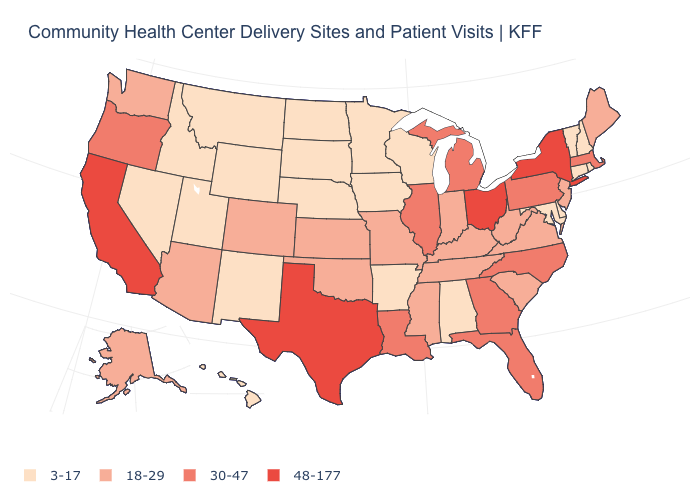Among the states that border New Jersey , does New York have the highest value?
Answer briefly. Yes. How many symbols are there in the legend?
Quick response, please. 4. Name the states that have a value in the range 3-17?
Write a very short answer. Alabama, Arkansas, Connecticut, Delaware, Hawaii, Idaho, Iowa, Maryland, Minnesota, Montana, Nebraska, Nevada, New Hampshire, New Mexico, North Dakota, Rhode Island, South Dakota, Utah, Vermont, Wisconsin, Wyoming. Name the states that have a value in the range 3-17?
Keep it brief. Alabama, Arkansas, Connecticut, Delaware, Hawaii, Idaho, Iowa, Maryland, Minnesota, Montana, Nebraska, Nevada, New Hampshire, New Mexico, North Dakota, Rhode Island, South Dakota, Utah, Vermont, Wisconsin, Wyoming. Name the states that have a value in the range 18-29?
Write a very short answer. Alaska, Arizona, Colorado, Indiana, Kansas, Kentucky, Maine, Mississippi, Missouri, New Jersey, Oklahoma, South Carolina, Tennessee, Virginia, Washington, West Virginia. What is the value of South Carolina?
Short answer required. 18-29. Among the states that border Illinois , which have the highest value?
Short answer required. Indiana, Kentucky, Missouri. Name the states that have a value in the range 48-177?
Keep it brief. California, New York, Ohio, Texas. What is the lowest value in states that border Pennsylvania?
Keep it brief. 3-17. What is the value of South Dakota?
Keep it brief. 3-17. Does New Jersey have the highest value in the USA?
Be succinct. No. Name the states that have a value in the range 30-47?
Short answer required. Florida, Georgia, Illinois, Louisiana, Massachusetts, Michigan, North Carolina, Oregon, Pennsylvania. What is the value of Nebraska?
Write a very short answer. 3-17. What is the lowest value in states that border California?
Concise answer only. 3-17. Name the states that have a value in the range 30-47?
Answer briefly. Florida, Georgia, Illinois, Louisiana, Massachusetts, Michigan, North Carolina, Oregon, Pennsylvania. 